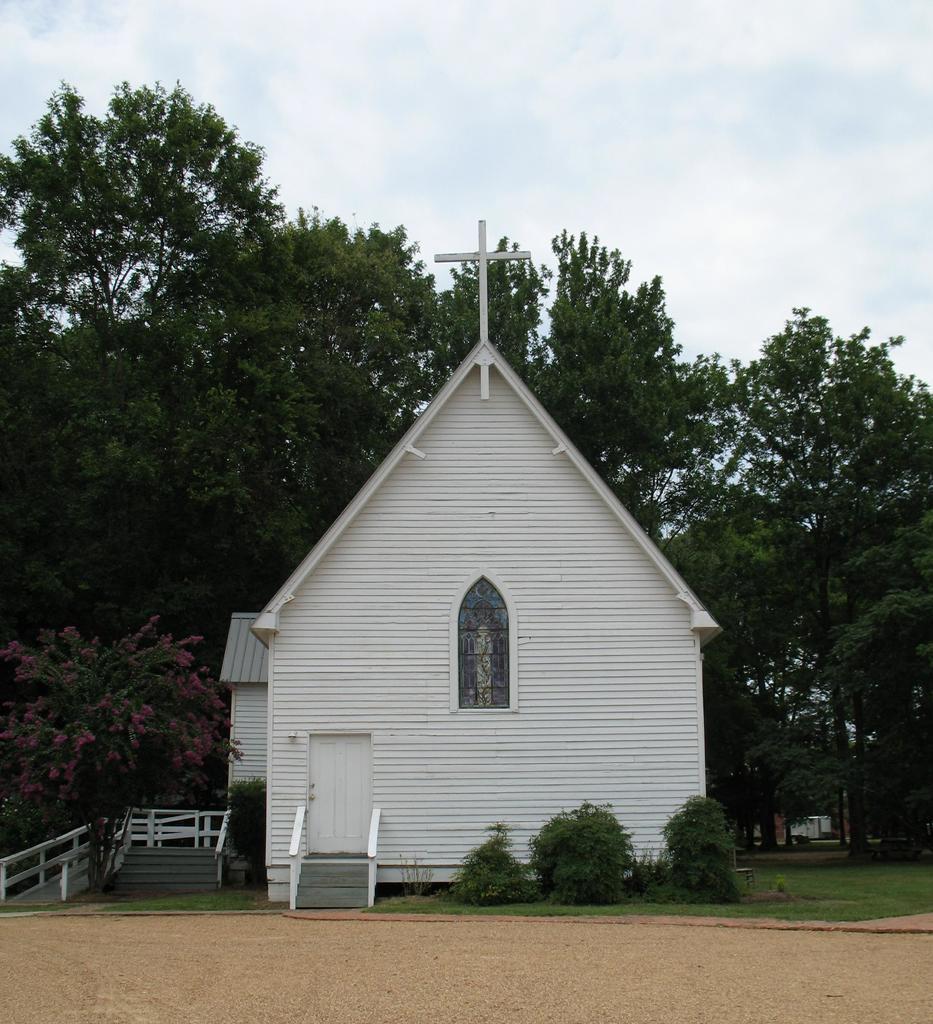Describe this image in one or two sentences. In this picture there are trees, plants, grass, staircase, soil and a church. Sky is cloudy. 